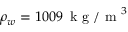<formula> <loc_0><loc_0><loc_500><loc_500>\rho _ { w } = 1 0 0 9 \, k g / m ^ { 3 }</formula> 